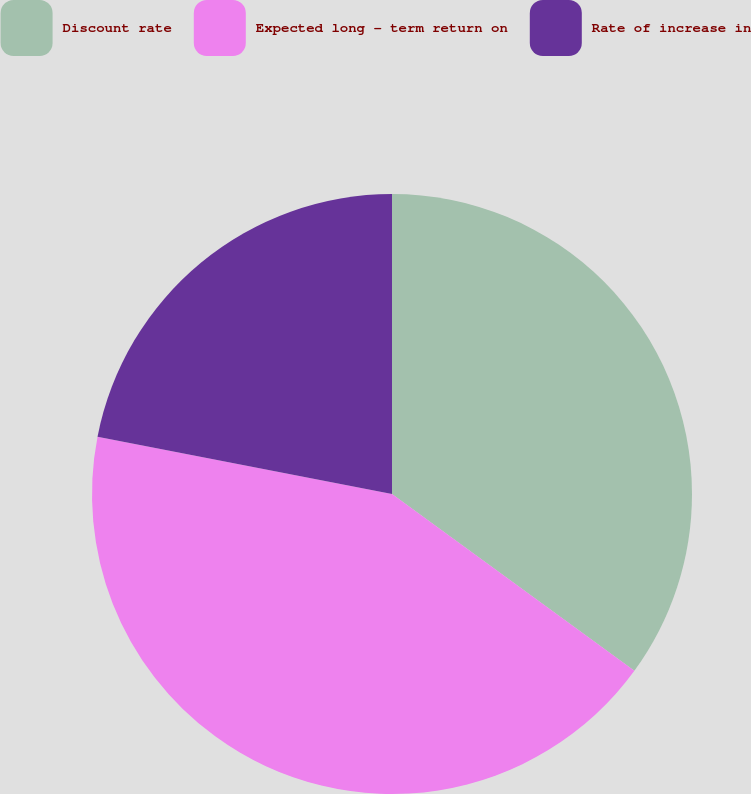Convert chart to OTSL. <chart><loc_0><loc_0><loc_500><loc_500><pie_chart><fcel>Discount rate<fcel>Expected long - term return on<fcel>Rate of increase in<nl><fcel>35.03%<fcel>43.03%<fcel>21.94%<nl></chart> 